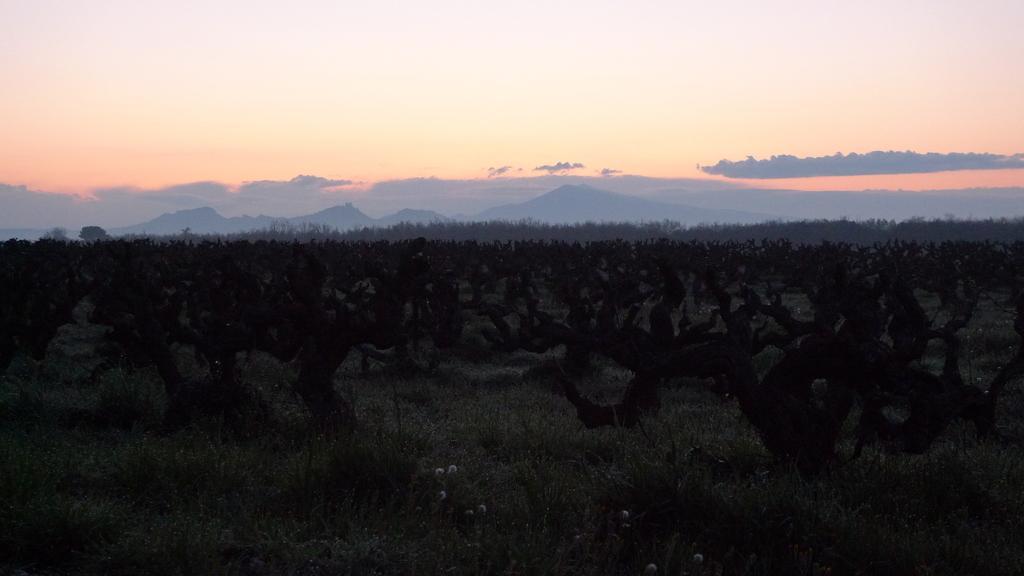Describe this image in one or two sentences. In this image I can see grass, trees and in the background I can see mountains, clouds and the sky. 